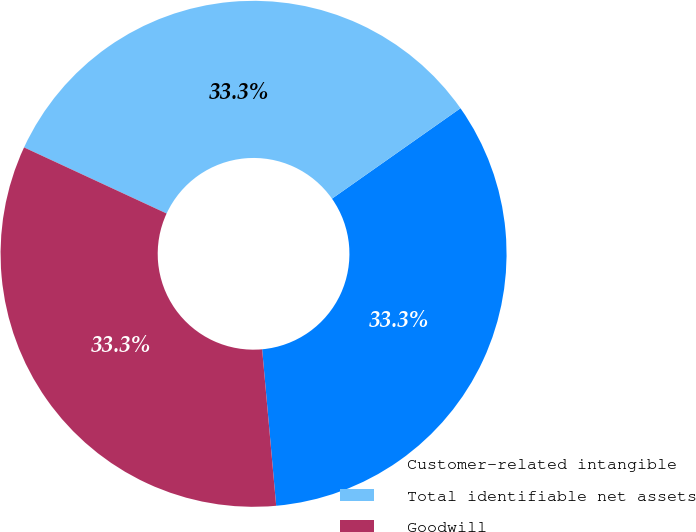Convert chart. <chart><loc_0><loc_0><loc_500><loc_500><pie_chart><fcel>Customer-related intangible<fcel>Total identifiable net assets<fcel>Goodwill<nl><fcel>33.33%<fcel>33.33%<fcel>33.33%<nl></chart> 